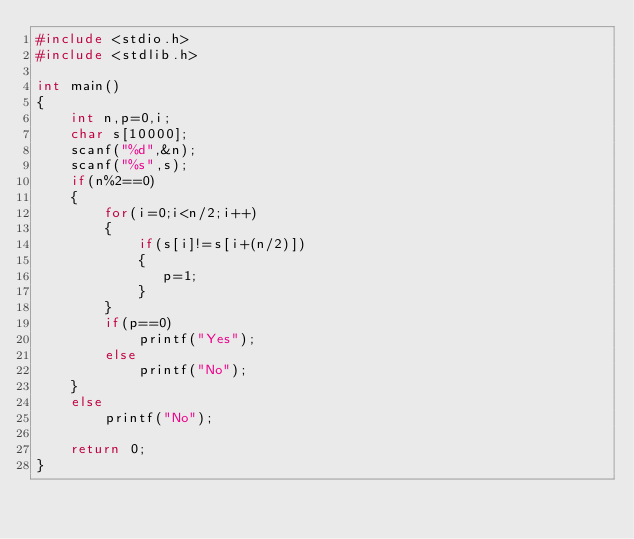Convert code to text. <code><loc_0><loc_0><loc_500><loc_500><_C_>#include <stdio.h>
#include <stdlib.h>

int main()
{
    int n,p=0,i;
    char s[10000];
    scanf("%d",&n);
    scanf("%s",s);
    if(n%2==0)
    {
        for(i=0;i<n/2;i++)
        {
            if(s[i]!=s[i+(n/2)])
            {
               p=1;
            }
        }
        if(p==0)
            printf("Yes");
        else
            printf("No");
    }
    else
        printf("No");

    return 0;
}
</code> 